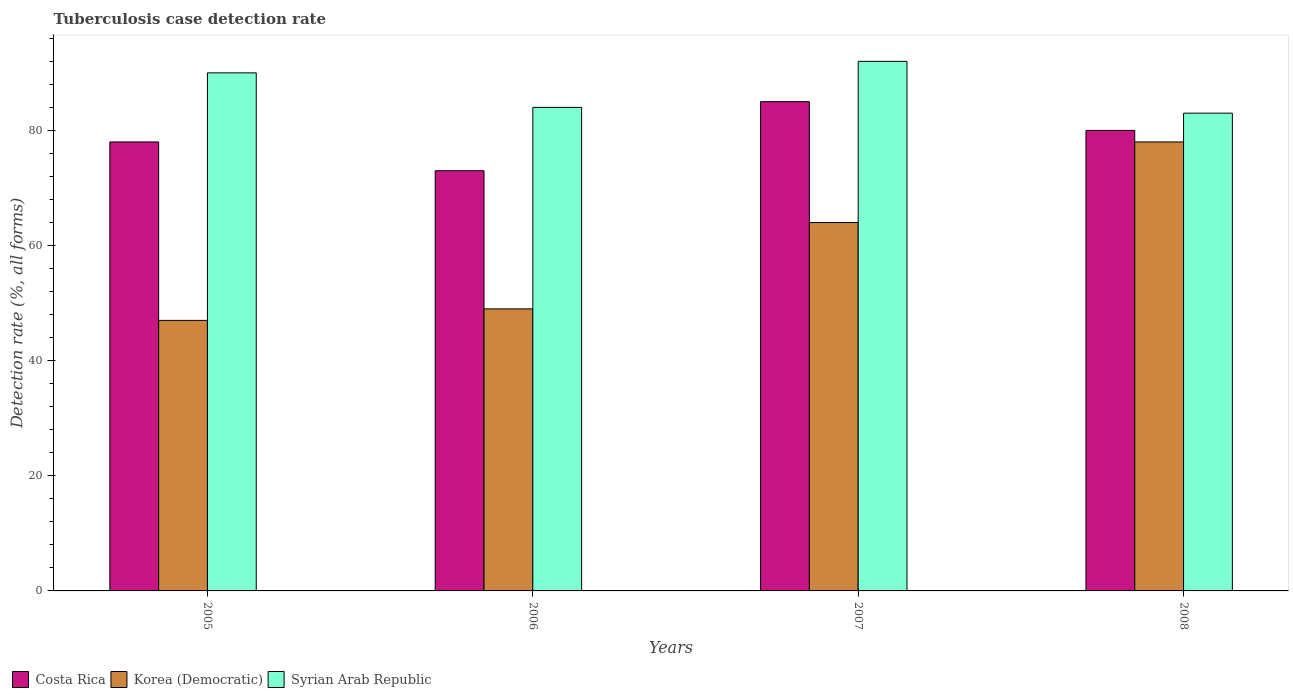How many different coloured bars are there?
Make the answer very short. 3. What is the tuberculosis case detection rate in in Costa Rica in 2005?
Keep it short and to the point. 78. Across all years, what is the maximum tuberculosis case detection rate in in Costa Rica?
Give a very brief answer. 85. Across all years, what is the minimum tuberculosis case detection rate in in Korea (Democratic)?
Provide a succinct answer. 47. In which year was the tuberculosis case detection rate in in Costa Rica maximum?
Ensure brevity in your answer.  2007. In which year was the tuberculosis case detection rate in in Syrian Arab Republic minimum?
Make the answer very short. 2008. What is the total tuberculosis case detection rate in in Korea (Democratic) in the graph?
Offer a very short reply. 238. What is the difference between the tuberculosis case detection rate in in Costa Rica in 2006 and that in 2008?
Your answer should be compact. -7. What is the difference between the tuberculosis case detection rate in in Syrian Arab Republic in 2007 and the tuberculosis case detection rate in in Korea (Democratic) in 2006?
Your response must be concise. 43. What is the average tuberculosis case detection rate in in Korea (Democratic) per year?
Offer a terse response. 59.5. In the year 2008, what is the difference between the tuberculosis case detection rate in in Costa Rica and tuberculosis case detection rate in in Syrian Arab Republic?
Offer a very short reply. -3. In how many years, is the tuberculosis case detection rate in in Costa Rica greater than 20 %?
Make the answer very short. 4. What is the ratio of the tuberculosis case detection rate in in Syrian Arab Republic in 2005 to that in 2007?
Ensure brevity in your answer.  0.98. What is the difference between the highest and the second highest tuberculosis case detection rate in in Syrian Arab Republic?
Make the answer very short. 2. What is the difference between the highest and the lowest tuberculosis case detection rate in in Korea (Democratic)?
Your answer should be very brief. 31. In how many years, is the tuberculosis case detection rate in in Korea (Democratic) greater than the average tuberculosis case detection rate in in Korea (Democratic) taken over all years?
Keep it short and to the point. 2. What does the 1st bar from the right in 2008 represents?
Ensure brevity in your answer.  Syrian Arab Republic. Is it the case that in every year, the sum of the tuberculosis case detection rate in in Korea (Democratic) and tuberculosis case detection rate in in Syrian Arab Republic is greater than the tuberculosis case detection rate in in Costa Rica?
Keep it short and to the point. Yes. Are all the bars in the graph horizontal?
Offer a terse response. No. How many years are there in the graph?
Offer a very short reply. 4. How many legend labels are there?
Ensure brevity in your answer.  3. What is the title of the graph?
Keep it short and to the point. Tuberculosis case detection rate. Does "Spain" appear as one of the legend labels in the graph?
Provide a succinct answer. No. What is the label or title of the Y-axis?
Your answer should be compact. Detection rate (%, all forms). What is the Detection rate (%, all forms) of Syrian Arab Republic in 2005?
Offer a terse response. 90. What is the Detection rate (%, all forms) in Costa Rica in 2006?
Your response must be concise. 73. What is the Detection rate (%, all forms) of Korea (Democratic) in 2006?
Your answer should be compact. 49. What is the Detection rate (%, all forms) in Korea (Democratic) in 2007?
Provide a succinct answer. 64. What is the Detection rate (%, all forms) in Syrian Arab Republic in 2007?
Your answer should be compact. 92. What is the Detection rate (%, all forms) of Costa Rica in 2008?
Make the answer very short. 80. What is the Detection rate (%, all forms) of Syrian Arab Republic in 2008?
Ensure brevity in your answer.  83. Across all years, what is the maximum Detection rate (%, all forms) of Korea (Democratic)?
Provide a succinct answer. 78. Across all years, what is the maximum Detection rate (%, all forms) in Syrian Arab Republic?
Offer a terse response. 92. What is the total Detection rate (%, all forms) in Costa Rica in the graph?
Your answer should be very brief. 316. What is the total Detection rate (%, all forms) of Korea (Democratic) in the graph?
Make the answer very short. 238. What is the total Detection rate (%, all forms) in Syrian Arab Republic in the graph?
Keep it short and to the point. 349. What is the difference between the Detection rate (%, all forms) of Syrian Arab Republic in 2005 and that in 2006?
Offer a very short reply. 6. What is the difference between the Detection rate (%, all forms) in Costa Rica in 2005 and that in 2007?
Your answer should be very brief. -7. What is the difference between the Detection rate (%, all forms) in Korea (Democratic) in 2005 and that in 2007?
Offer a terse response. -17. What is the difference between the Detection rate (%, all forms) of Korea (Democratic) in 2005 and that in 2008?
Make the answer very short. -31. What is the difference between the Detection rate (%, all forms) in Syrian Arab Republic in 2005 and that in 2008?
Provide a short and direct response. 7. What is the difference between the Detection rate (%, all forms) of Costa Rica in 2006 and that in 2007?
Your answer should be very brief. -12. What is the difference between the Detection rate (%, all forms) of Syrian Arab Republic in 2006 and that in 2007?
Offer a very short reply. -8. What is the difference between the Detection rate (%, all forms) of Costa Rica in 2007 and that in 2008?
Provide a short and direct response. 5. What is the difference between the Detection rate (%, all forms) of Syrian Arab Republic in 2007 and that in 2008?
Ensure brevity in your answer.  9. What is the difference between the Detection rate (%, all forms) in Costa Rica in 2005 and the Detection rate (%, all forms) in Syrian Arab Republic in 2006?
Ensure brevity in your answer.  -6. What is the difference between the Detection rate (%, all forms) in Korea (Democratic) in 2005 and the Detection rate (%, all forms) in Syrian Arab Republic in 2006?
Offer a terse response. -37. What is the difference between the Detection rate (%, all forms) in Costa Rica in 2005 and the Detection rate (%, all forms) in Korea (Democratic) in 2007?
Ensure brevity in your answer.  14. What is the difference between the Detection rate (%, all forms) in Korea (Democratic) in 2005 and the Detection rate (%, all forms) in Syrian Arab Republic in 2007?
Keep it short and to the point. -45. What is the difference between the Detection rate (%, all forms) of Costa Rica in 2005 and the Detection rate (%, all forms) of Syrian Arab Republic in 2008?
Keep it short and to the point. -5. What is the difference between the Detection rate (%, all forms) in Korea (Democratic) in 2005 and the Detection rate (%, all forms) in Syrian Arab Republic in 2008?
Make the answer very short. -36. What is the difference between the Detection rate (%, all forms) in Costa Rica in 2006 and the Detection rate (%, all forms) in Korea (Democratic) in 2007?
Make the answer very short. 9. What is the difference between the Detection rate (%, all forms) in Korea (Democratic) in 2006 and the Detection rate (%, all forms) in Syrian Arab Republic in 2007?
Provide a succinct answer. -43. What is the difference between the Detection rate (%, all forms) in Costa Rica in 2006 and the Detection rate (%, all forms) in Korea (Democratic) in 2008?
Your response must be concise. -5. What is the difference between the Detection rate (%, all forms) in Korea (Democratic) in 2006 and the Detection rate (%, all forms) in Syrian Arab Republic in 2008?
Provide a short and direct response. -34. What is the difference between the Detection rate (%, all forms) in Costa Rica in 2007 and the Detection rate (%, all forms) in Syrian Arab Republic in 2008?
Ensure brevity in your answer.  2. What is the difference between the Detection rate (%, all forms) of Korea (Democratic) in 2007 and the Detection rate (%, all forms) of Syrian Arab Republic in 2008?
Your response must be concise. -19. What is the average Detection rate (%, all forms) of Costa Rica per year?
Provide a succinct answer. 79. What is the average Detection rate (%, all forms) of Korea (Democratic) per year?
Offer a terse response. 59.5. What is the average Detection rate (%, all forms) of Syrian Arab Republic per year?
Give a very brief answer. 87.25. In the year 2005, what is the difference between the Detection rate (%, all forms) of Costa Rica and Detection rate (%, all forms) of Syrian Arab Republic?
Your response must be concise. -12. In the year 2005, what is the difference between the Detection rate (%, all forms) of Korea (Democratic) and Detection rate (%, all forms) of Syrian Arab Republic?
Provide a short and direct response. -43. In the year 2006, what is the difference between the Detection rate (%, all forms) of Costa Rica and Detection rate (%, all forms) of Korea (Democratic)?
Your response must be concise. 24. In the year 2006, what is the difference between the Detection rate (%, all forms) in Costa Rica and Detection rate (%, all forms) in Syrian Arab Republic?
Give a very brief answer. -11. In the year 2006, what is the difference between the Detection rate (%, all forms) of Korea (Democratic) and Detection rate (%, all forms) of Syrian Arab Republic?
Provide a succinct answer. -35. In the year 2007, what is the difference between the Detection rate (%, all forms) of Costa Rica and Detection rate (%, all forms) of Syrian Arab Republic?
Provide a short and direct response. -7. In the year 2008, what is the difference between the Detection rate (%, all forms) in Costa Rica and Detection rate (%, all forms) in Korea (Democratic)?
Offer a terse response. 2. What is the ratio of the Detection rate (%, all forms) in Costa Rica in 2005 to that in 2006?
Give a very brief answer. 1.07. What is the ratio of the Detection rate (%, all forms) of Korea (Democratic) in 2005 to that in 2006?
Give a very brief answer. 0.96. What is the ratio of the Detection rate (%, all forms) of Syrian Arab Republic in 2005 to that in 2006?
Your answer should be compact. 1.07. What is the ratio of the Detection rate (%, all forms) in Costa Rica in 2005 to that in 2007?
Offer a very short reply. 0.92. What is the ratio of the Detection rate (%, all forms) of Korea (Democratic) in 2005 to that in 2007?
Give a very brief answer. 0.73. What is the ratio of the Detection rate (%, all forms) in Syrian Arab Republic in 2005 to that in 2007?
Your answer should be very brief. 0.98. What is the ratio of the Detection rate (%, all forms) in Costa Rica in 2005 to that in 2008?
Provide a succinct answer. 0.97. What is the ratio of the Detection rate (%, all forms) in Korea (Democratic) in 2005 to that in 2008?
Your response must be concise. 0.6. What is the ratio of the Detection rate (%, all forms) in Syrian Arab Republic in 2005 to that in 2008?
Your answer should be compact. 1.08. What is the ratio of the Detection rate (%, all forms) of Costa Rica in 2006 to that in 2007?
Offer a very short reply. 0.86. What is the ratio of the Detection rate (%, all forms) of Korea (Democratic) in 2006 to that in 2007?
Ensure brevity in your answer.  0.77. What is the ratio of the Detection rate (%, all forms) of Costa Rica in 2006 to that in 2008?
Keep it short and to the point. 0.91. What is the ratio of the Detection rate (%, all forms) in Korea (Democratic) in 2006 to that in 2008?
Your response must be concise. 0.63. What is the ratio of the Detection rate (%, all forms) in Syrian Arab Republic in 2006 to that in 2008?
Your answer should be very brief. 1.01. What is the ratio of the Detection rate (%, all forms) of Korea (Democratic) in 2007 to that in 2008?
Give a very brief answer. 0.82. What is the ratio of the Detection rate (%, all forms) in Syrian Arab Republic in 2007 to that in 2008?
Provide a short and direct response. 1.11. What is the difference between the highest and the second highest Detection rate (%, all forms) in Korea (Democratic)?
Provide a succinct answer. 14. What is the difference between the highest and the lowest Detection rate (%, all forms) of Costa Rica?
Offer a terse response. 12. What is the difference between the highest and the lowest Detection rate (%, all forms) of Syrian Arab Republic?
Provide a succinct answer. 9. 